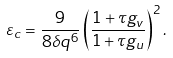<formula> <loc_0><loc_0><loc_500><loc_500>\varepsilon _ { c } = \frac { 9 } { 8 \delta q ^ { 6 } } \left ( \frac { 1 + \tau g _ { v } } { 1 + \tau g _ { u } } \right ) ^ { 2 } .</formula> 